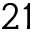<formula> <loc_0><loc_0><loc_500><loc_500>2 1</formula> 